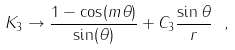<formula> <loc_0><loc_0><loc_500><loc_500>K _ { 3 } \to \frac { 1 - \cos ( m \theta ) } { \sin ( \theta ) } + C _ { 3 } \frac { \sin \theta } { r } \ ,</formula> 